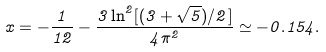<formula> <loc_0><loc_0><loc_500><loc_500>x = - \frac { 1 } { 1 2 } - \frac { 3 \ln ^ { 2 } [ ( 3 + \sqrt { 5 } ) / 2 ] } { 4 \pi ^ { 2 } } \simeq - 0 . 1 5 4 .</formula> 